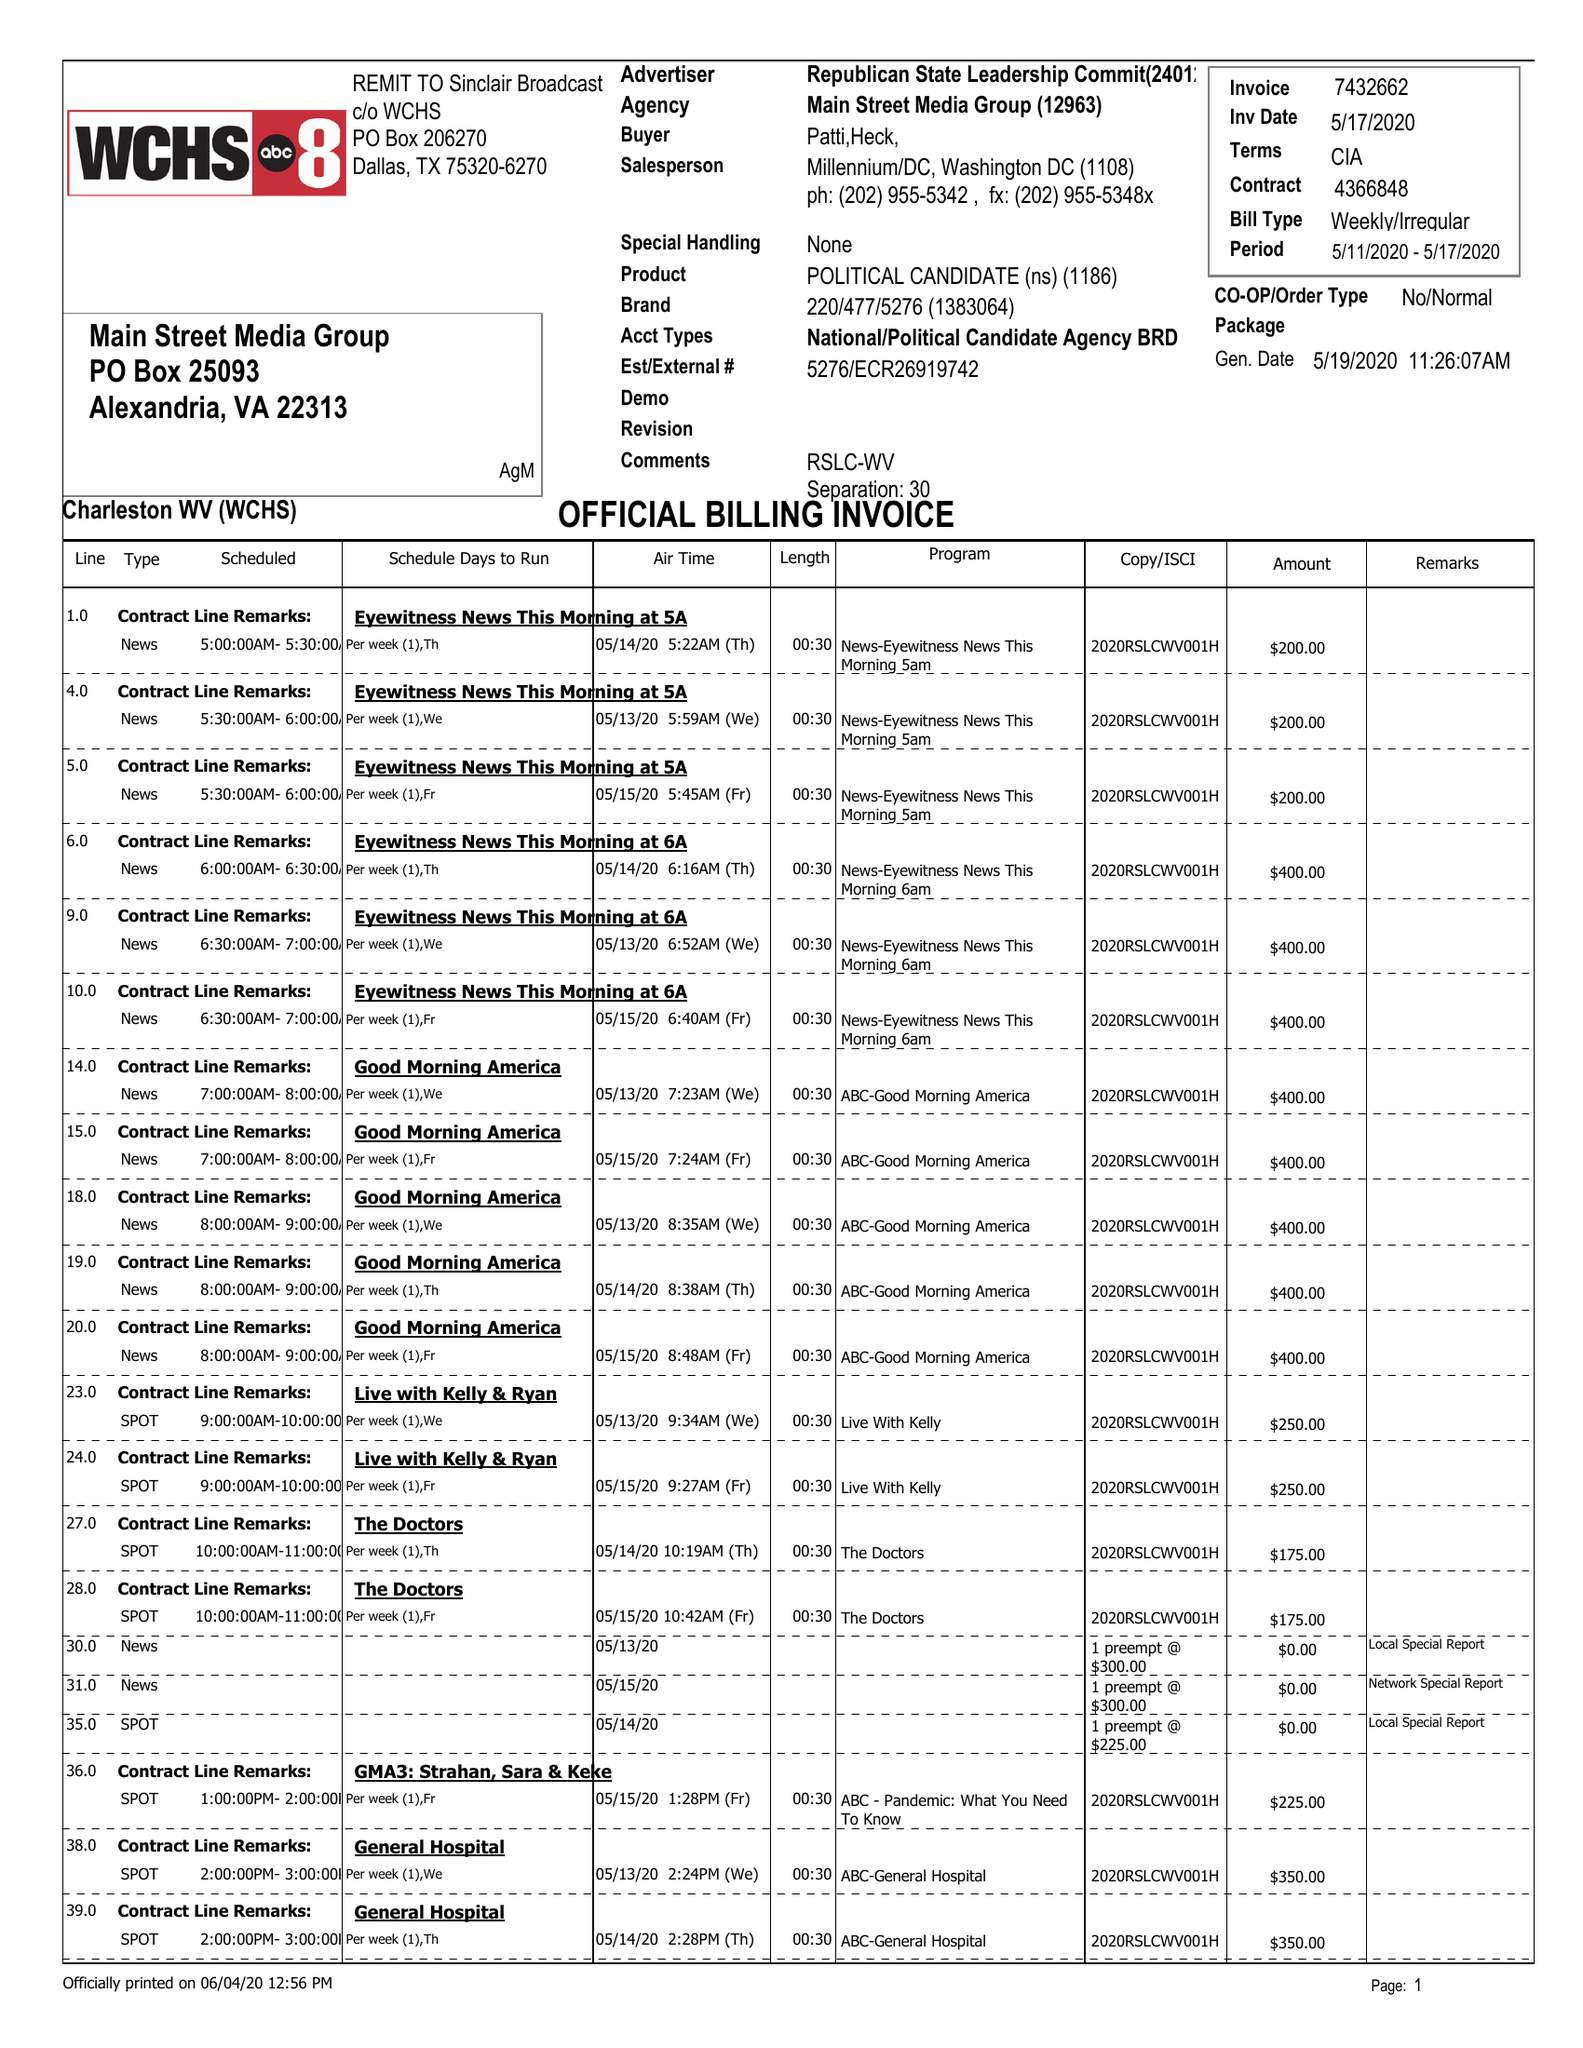What is the value for the flight_from?
Answer the question using a single word or phrase. 05/11/20 